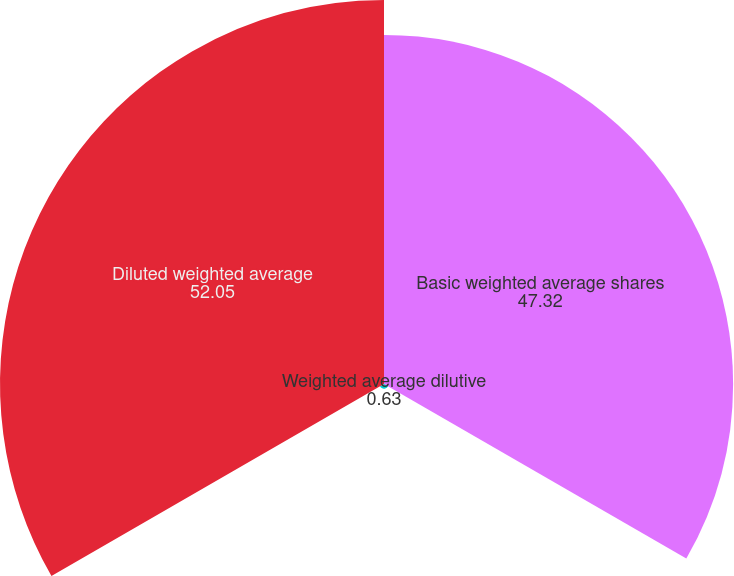<chart> <loc_0><loc_0><loc_500><loc_500><pie_chart><fcel>Basic weighted average shares<fcel>Weighted average dilutive<fcel>Diluted weighted average<nl><fcel>47.32%<fcel>0.63%<fcel>52.05%<nl></chart> 